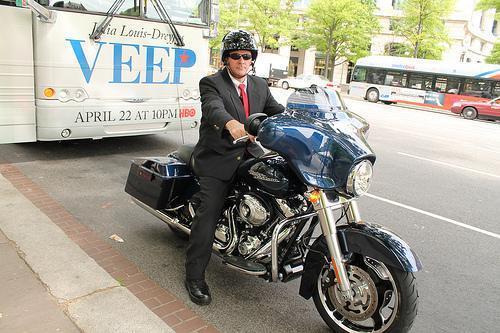How many buses are shown?
Give a very brief answer. 2. 